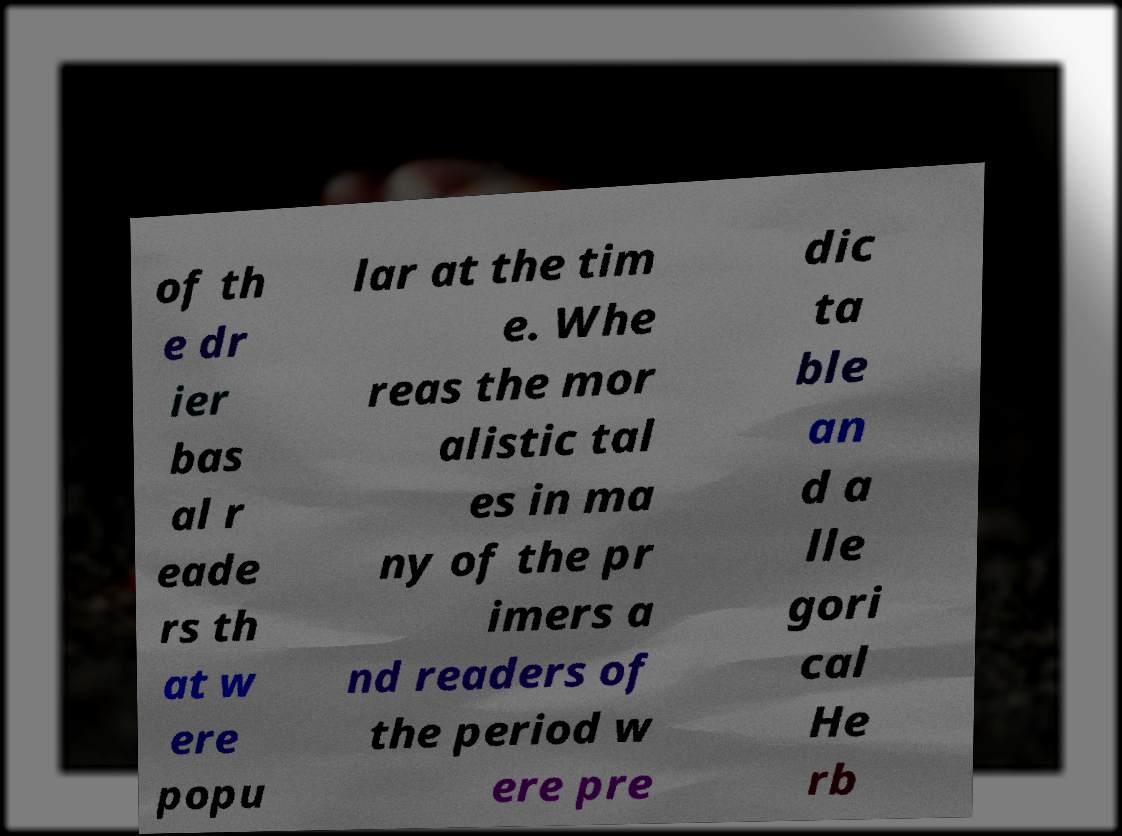Can you read and provide the text displayed in the image?This photo seems to have some interesting text. Can you extract and type it out for me? of th e dr ier bas al r eade rs th at w ere popu lar at the tim e. Whe reas the mor alistic tal es in ma ny of the pr imers a nd readers of the period w ere pre dic ta ble an d a lle gori cal He rb 